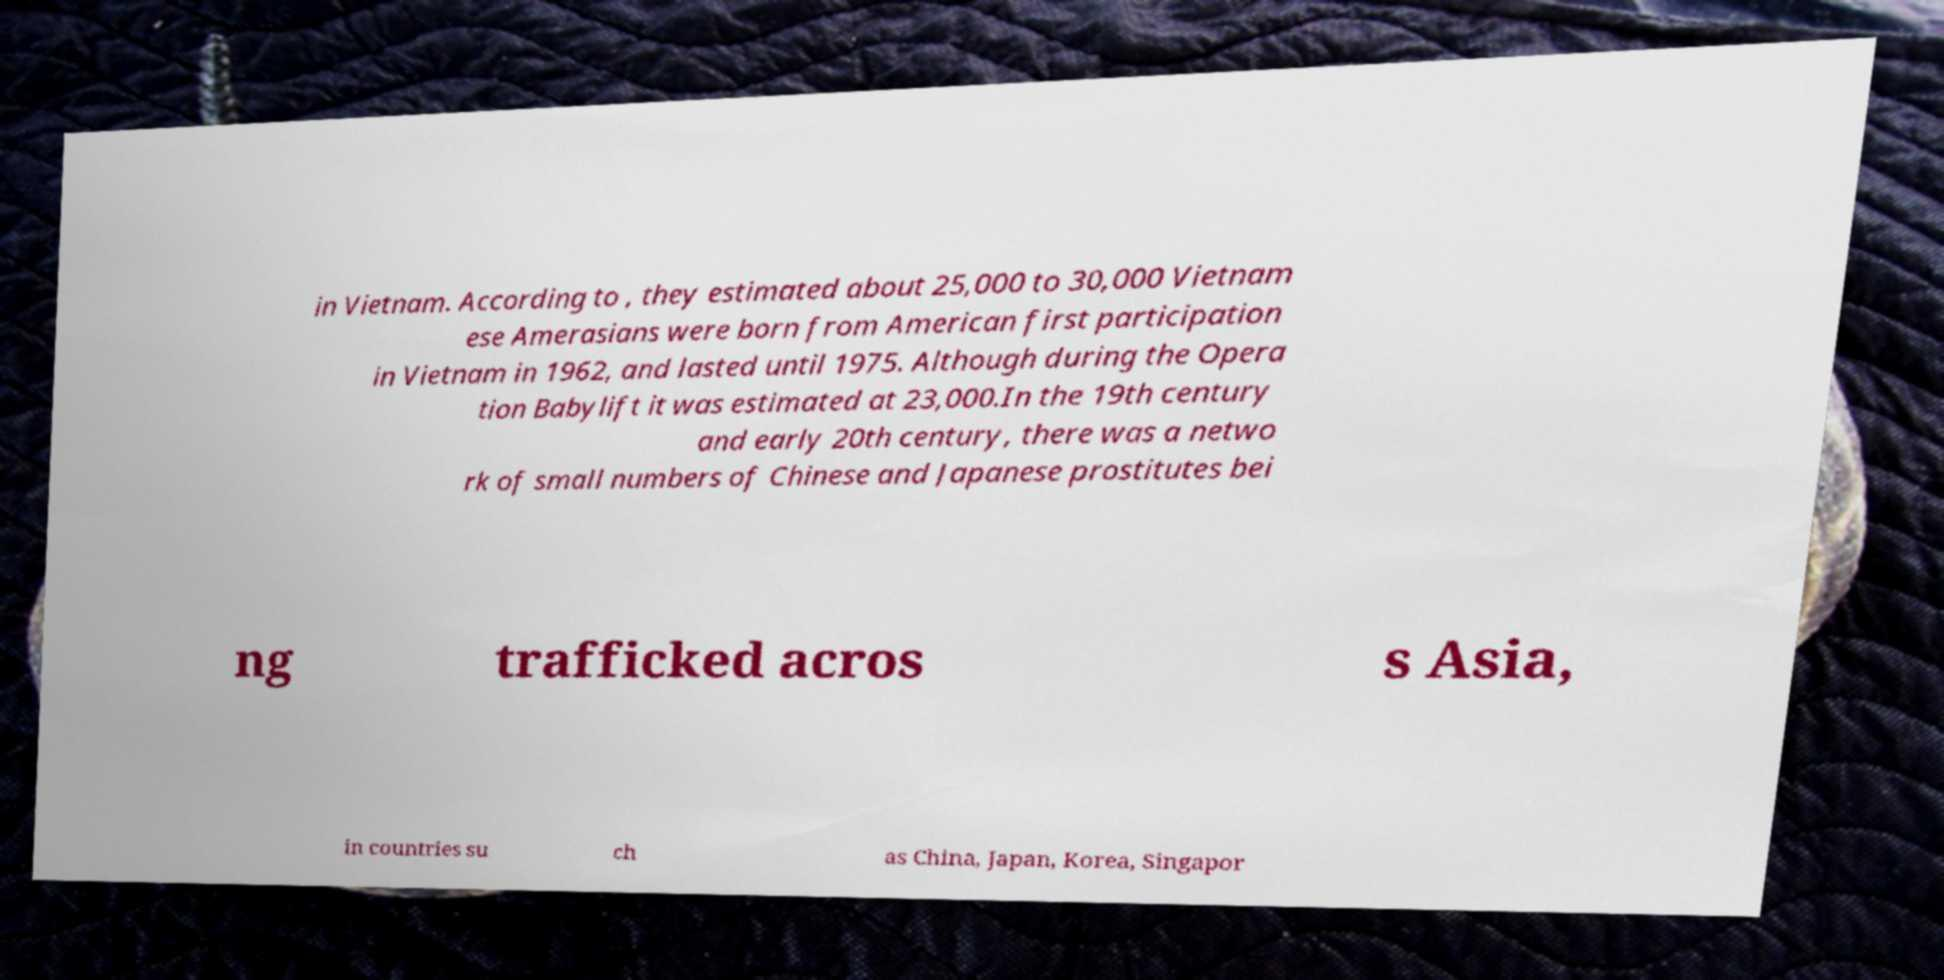Can you accurately transcribe the text from the provided image for me? in Vietnam. According to , they estimated about 25,000 to 30,000 Vietnam ese Amerasians were born from American first participation in Vietnam in 1962, and lasted until 1975. Although during the Opera tion Babylift it was estimated at 23,000.In the 19th century and early 20th century, there was a netwo rk of small numbers of Chinese and Japanese prostitutes bei ng trafficked acros s Asia, in countries su ch as China, Japan, Korea, Singapor 